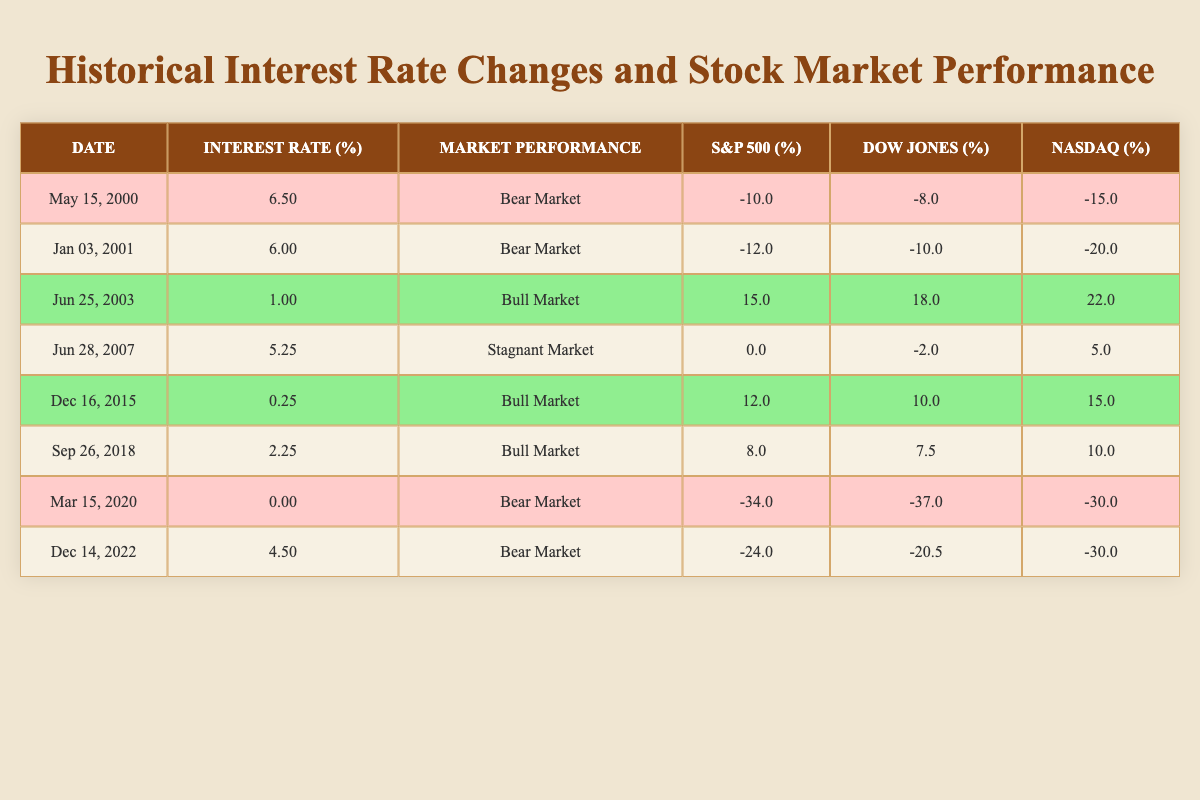What was the interest rate on June 25, 2003? The table shows that on June 25, 2003, the interest rate was 1.00 percent.
Answer: 1.00 In which year did the stock market first show performance categorized as a Bull Market? Looking at the table, the first instance of a Bull Market occurred on June 25, 2003, which is in the year 2003.
Answer: 2003 What was the average decline in the major indices during the Bear Market on March 15, 2020? The major indices declined as follows: S&P 500: -34.0, Dow Jones: -37.0, NASDAQ: -30.0. The average decline is calculated as (-34.0 - 37.0 - 30.0)/3 = -33.67.
Answer: -33.67 Is it true that an interest rate of 0.25 percent always corresponds to a Bull Market? Checking the table, the interest rate of 0.25 percent corresponds to a Bull Market only once on December 16, 2015. Therefore, it does not always correspond to a Bull Market.
Answer: No What was the stock market performance for each interest rate above 4 percent? From the table, the performance was Bear Market at both 6.50 (May 15, 2000) and 6.00 (January 3, 2001). At 5.25 (June 28, 2007) it was Stagnant Market, and at 4.50 (December 14, 2022) it was again Bear Market.
Answer: Bear, Bear, Stagnant, Bear 